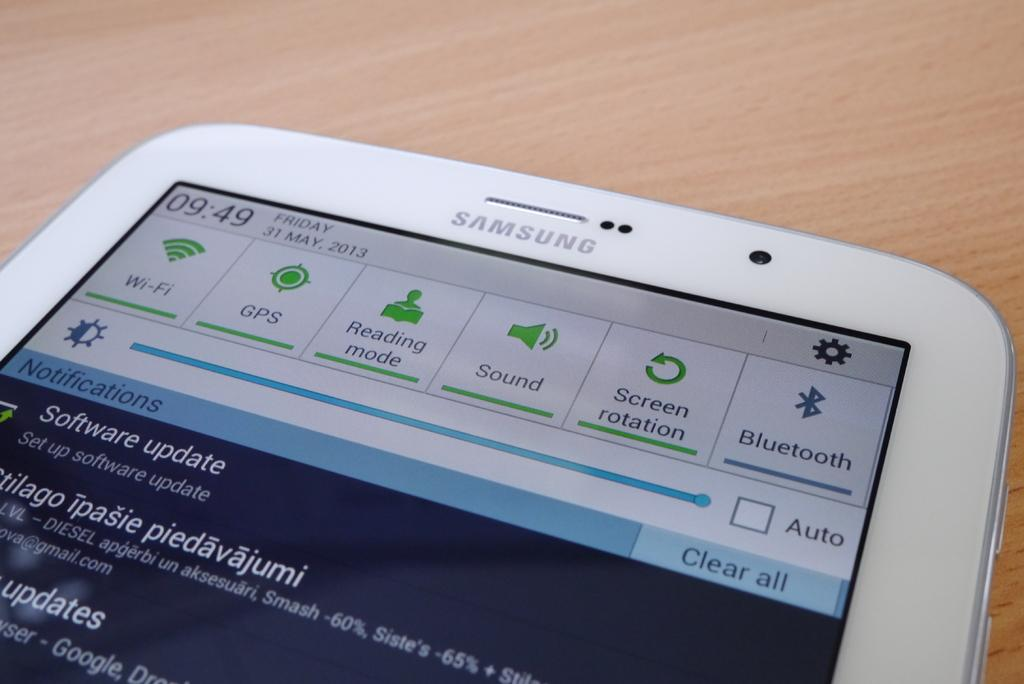<image>
Write a terse but informative summary of the picture. The screen of a Samsung phone showing the wifi, gps and sound among other features. 